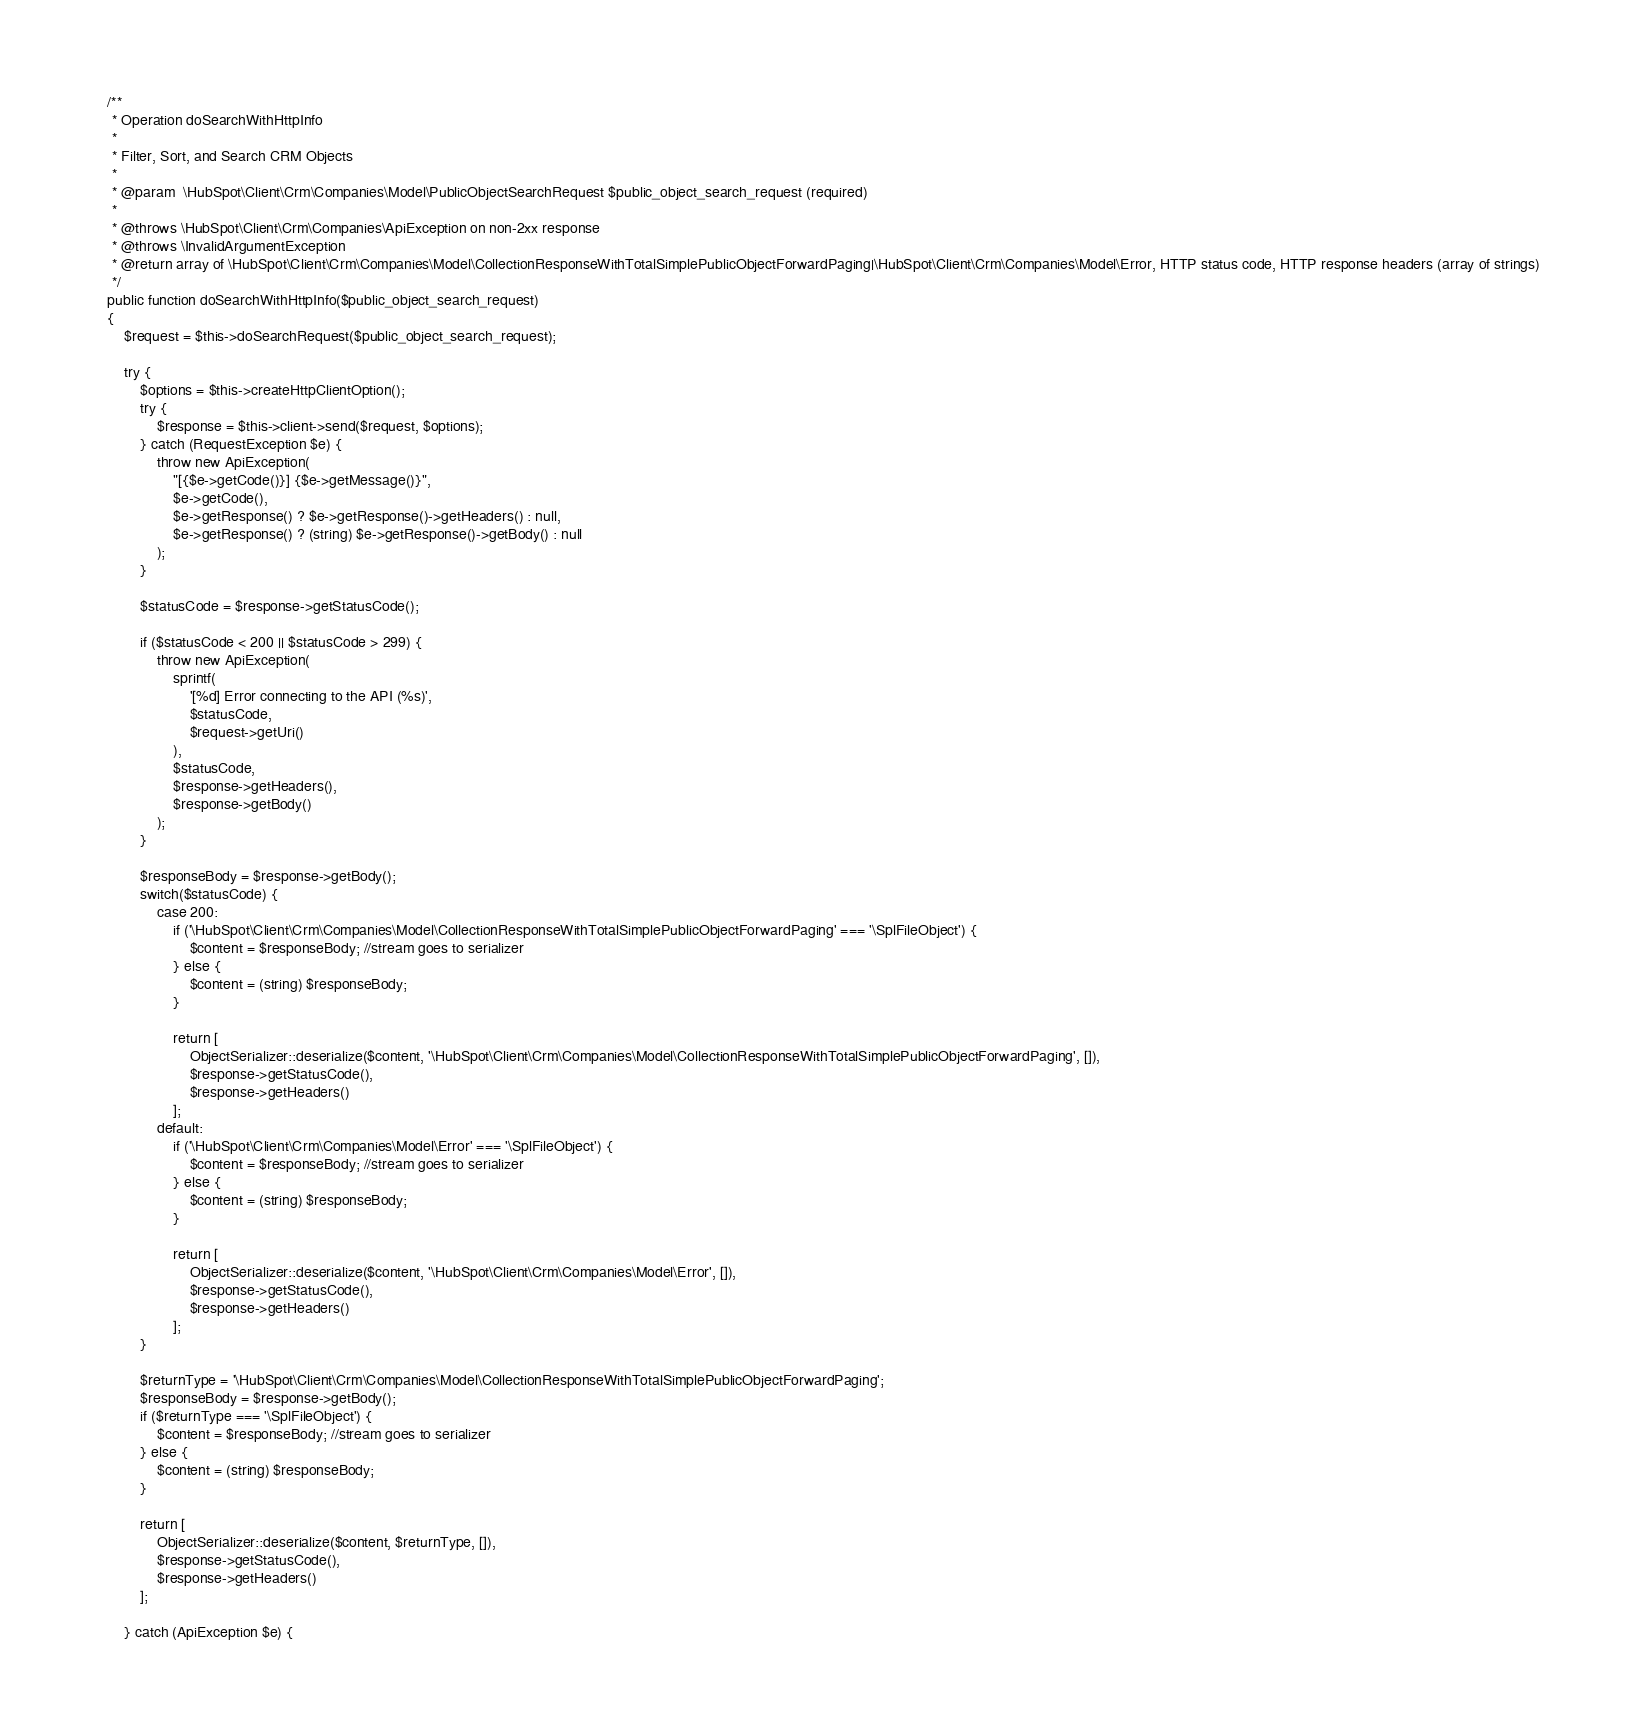<code> <loc_0><loc_0><loc_500><loc_500><_PHP_>
    /**
     * Operation doSearchWithHttpInfo
     *
     * Filter, Sort, and Search CRM Objects
     *
     * @param  \HubSpot\Client\Crm\Companies\Model\PublicObjectSearchRequest $public_object_search_request (required)
     *
     * @throws \HubSpot\Client\Crm\Companies\ApiException on non-2xx response
     * @throws \InvalidArgumentException
     * @return array of \HubSpot\Client\Crm\Companies\Model\CollectionResponseWithTotalSimplePublicObjectForwardPaging|\HubSpot\Client\Crm\Companies\Model\Error, HTTP status code, HTTP response headers (array of strings)
     */
    public function doSearchWithHttpInfo($public_object_search_request)
    {
        $request = $this->doSearchRequest($public_object_search_request);

        try {
            $options = $this->createHttpClientOption();
            try {
                $response = $this->client->send($request, $options);
            } catch (RequestException $e) {
                throw new ApiException(
                    "[{$e->getCode()}] {$e->getMessage()}",
                    $e->getCode(),
                    $e->getResponse() ? $e->getResponse()->getHeaders() : null,
                    $e->getResponse() ? (string) $e->getResponse()->getBody() : null
                );
            }

            $statusCode = $response->getStatusCode();

            if ($statusCode < 200 || $statusCode > 299) {
                throw new ApiException(
                    sprintf(
                        '[%d] Error connecting to the API (%s)',
                        $statusCode,
                        $request->getUri()
                    ),
                    $statusCode,
                    $response->getHeaders(),
                    $response->getBody()
                );
            }

            $responseBody = $response->getBody();
            switch($statusCode) {
                case 200:
                    if ('\HubSpot\Client\Crm\Companies\Model\CollectionResponseWithTotalSimplePublicObjectForwardPaging' === '\SplFileObject') {
                        $content = $responseBody; //stream goes to serializer
                    } else {
                        $content = (string) $responseBody;
                    }

                    return [
                        ObjectSerializer::deserialize($content, '\HubSpot\Client\Crm\Companies\Model\CollectionResponseWithTotalSimplePublicObjectForwardPaging', []),
                        $response->getStatusCode(),
                        $response->getHeaders()
                    ];
                default:
                    if ('\HubSpot\Client\Crm\Companies\Model\Error' === '\SplFileObject') {
                        $content = $responseBody; //stream goes to serializer
                    } else {
                        $content = (string) $responseBody;
                    }

                    return [
                        ObjectSerializer::deserialize($content, '\HubSpot\Client\Crm\Companies\Model\Error', []),
                        $response->getStatusCode(),
                        $response->getHeaders()
                    ];
            }

            $returnType = '\HubSpot\Client\Crm\Companies\Model\CollectionResponseWithTotalSimplePublicObjectForwardPaging';
            $responseBody = $response->getBody();
            if ($returnType === '\SplFileObject') {
                $content = $responseBody; //stream goes to serializer
            } else {
                $content = (string) $responseBody;
            }

            return [
                ObjectSerializer::deserialize($content, $returnType, []),
                $response->getStatusCode(),
                $response->getHeaders()
            ];

        } catch (ApiException $e) {</code> 